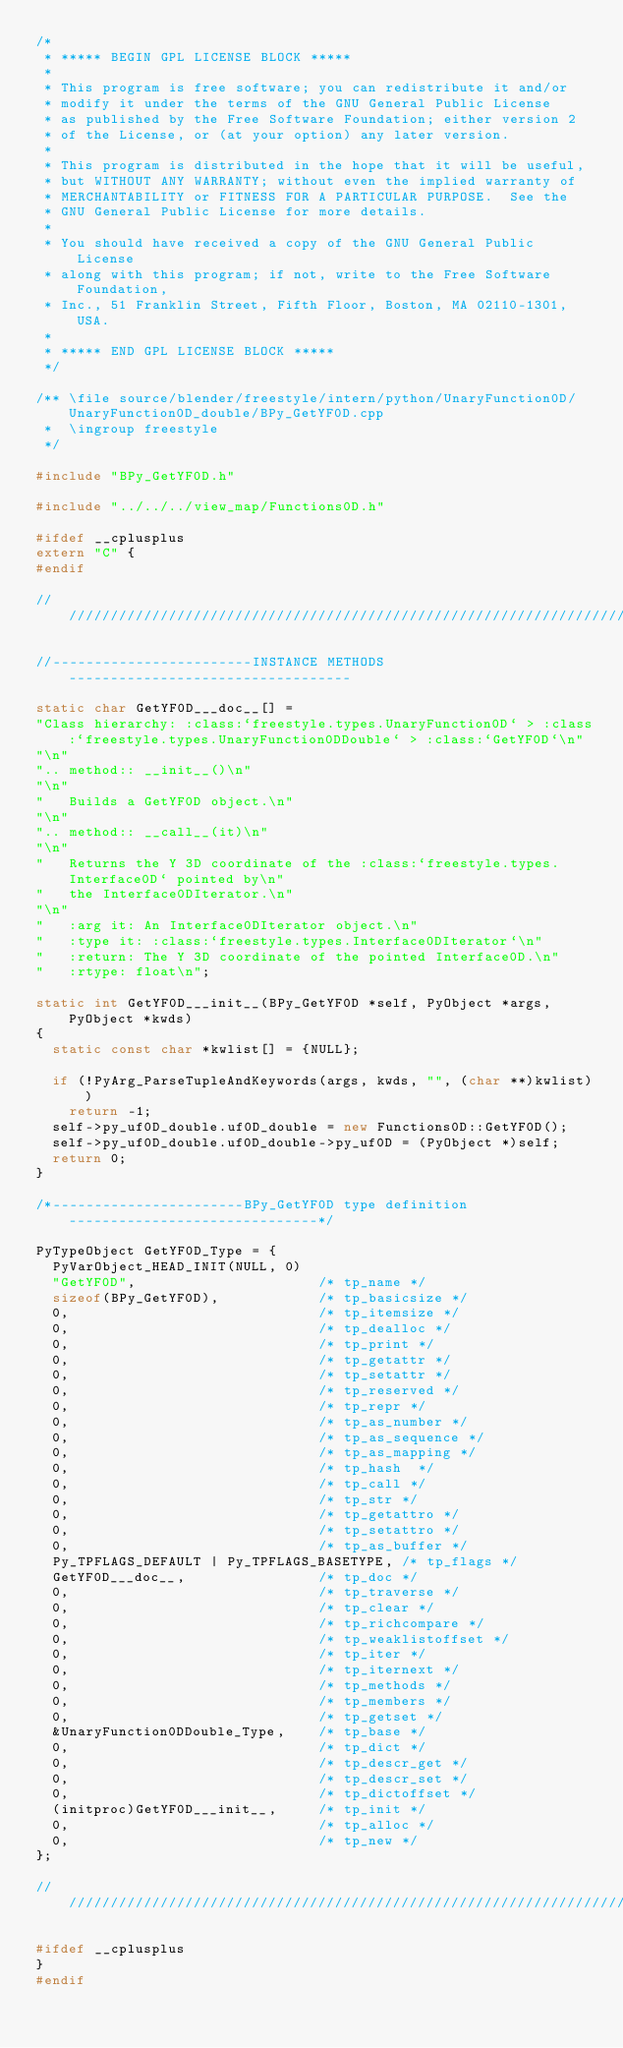<code> <loc_0><loc_0><loc_500><loc_500><_C++_>/*
 * ***** BEGIN GPL LICENSE BLOCK *****
 *
 * This program is free software; you can redistribute it and/or
 * modify it under the terms of the GNU General Public License
 * as published by the Free Software Foundation; either version 2
 * of the License, or (at your option) any later version.
 *
 * This program is distributed in the hope that it will be useful,
 * but WITHOUT ANY WARRANTY; without even the implied warranty of
 * MERCHANTABILITY or FITNESS FOR A PARTICULAR PURPOSE.  See the
 * GNU General Public License for more details.
 *
 * You should have received a copy of the GNU General Public License
 * along with this program; if not, write to the Free Software Foundation,
 * Inc., 51 Franklin Street, Fifth Floor, Boston, MA 02110-1301, USA.
 *
 * ***** END GPL LICENSE BLOCK *****
 */

/** \file source/blender/freestyle/intern/python/UnaryFunction0D/UnaryFunction0D_double/BPy_GetYF0D.cpp
 *  \ingroup freestyle
 */

#include "BPy_GetYF0D.h"

#include "../../../view_map/Functions0D.h"

#ifdef __cplusplus
extern "C" {
#endif

///////////////////////////////////////////////////////////////////////////////////////////

//------------------------INSTANCE METHODS ----------------------------------

static char GetYF0D___doc__[] =
"Class hierarchy: :class:`freestyle.types.UnaryFunction0D` > :class:`freestyle.types.UnaryFunction0DDouble` > :class:`GetYF0D`\n"
"\n"
".. method:: __init__()\n"
"\n"
"   Builds a GetYF0D object.\n"
"\n"
".. method:: __call__(it)\n"
"\n"
"   Returns the Y 3D coordinate of the :class:`freestyle.types.Interface0D` pointed by\n"
"   the Interface0DIterator.\n"
"\n"
"   :arg it: An Interface0DIterator object.\n"
"   :type it: :class:`freestyle.types.Interface0DIterator`\n"
"   :return: The Y 3D coordinate of the pointed Interface0D.\n"
"   :rtype: float\n";

static int GetYF0D___init__(BPy_GetYF0D *self, PyObject *args, PyObject *kwds)
{
	static const char *kwlist[] = {NULL};

	if (!PyArg_ParseTupleAndKeywords(args, kwds, "", (char **)kwlist))
		return -1;
	self->py_uf0D_double.uf0D_double = new Functions0D::GetYF0D();
	self->py_uf0D_double.uf0D_double->py_uf0D = (PyObject *)self;
	return 0;
}

/*-----------------------BPy_GetYF0D type definition ------------------------------*/

PyTypeObject GetYF0D_Type = {
	PyVarObject_HEAD_INIT(NULL, 0)
	"GetYF0D",                      /* tp_name */
	sizeof(BPy_GetYF0D),            /* tp_basicsize */
	0,                              /* tp_itemsize */
	0,                              /* tp_dealloc */
	0,                              /* tp_print */
	0,                              /* tp_getattr */
	0,                              /* tp_setattr */
	0,                              /* tp_reserved */
	0,                              /* tp_repr */
	0,                              /* tp_as_number */
	0,                              /* tp_as_sequence */
	0,                              /* tp_as_mapping */
	0,                              /* tp_hash  */
	0,                              /* tp_call */
	0,                              /* tp_str */
	0,                              /* tp_getattro */
	0,                              /* tp_setattro */
	0,                              /* tp_as_buffer */
	Py_TPFLAGS_DEFAULT | Py_TPFLAGS_BASETYPE, /* tp_flags */
	GetYF0D___doc__,                /* tp_doc */
	0,                              /* tp_traverse */
	0,                              /* tp_clear */
	0,                              /* tp_richcompare */
	0,                              /* tp_weaklistoffset */
	0,                              /* tp_iter */
	0,                              /* tp_iternext */
	0,                              /* tp_methods */
	0,                              /* tp_members */
	0,                              /* tp_getset */
	&UnaryFunction0DDouble_Type,    /* tp_base */
	0,                              /* tp_dict */
	0,                              /* tp_descr_get */
	0,                              /* tp_descr_set */
	0,                              /* tp_dictoffset */
	(initproc)GetYF0D___init__,     /* tp_init */
	0,                              /* tp_alloc */
	0,                              /* tp_new */
};

///////////////////////////////////////////////////////////////////////////////////////////

#ifdef __cplusplus
}
#endif
</code> 